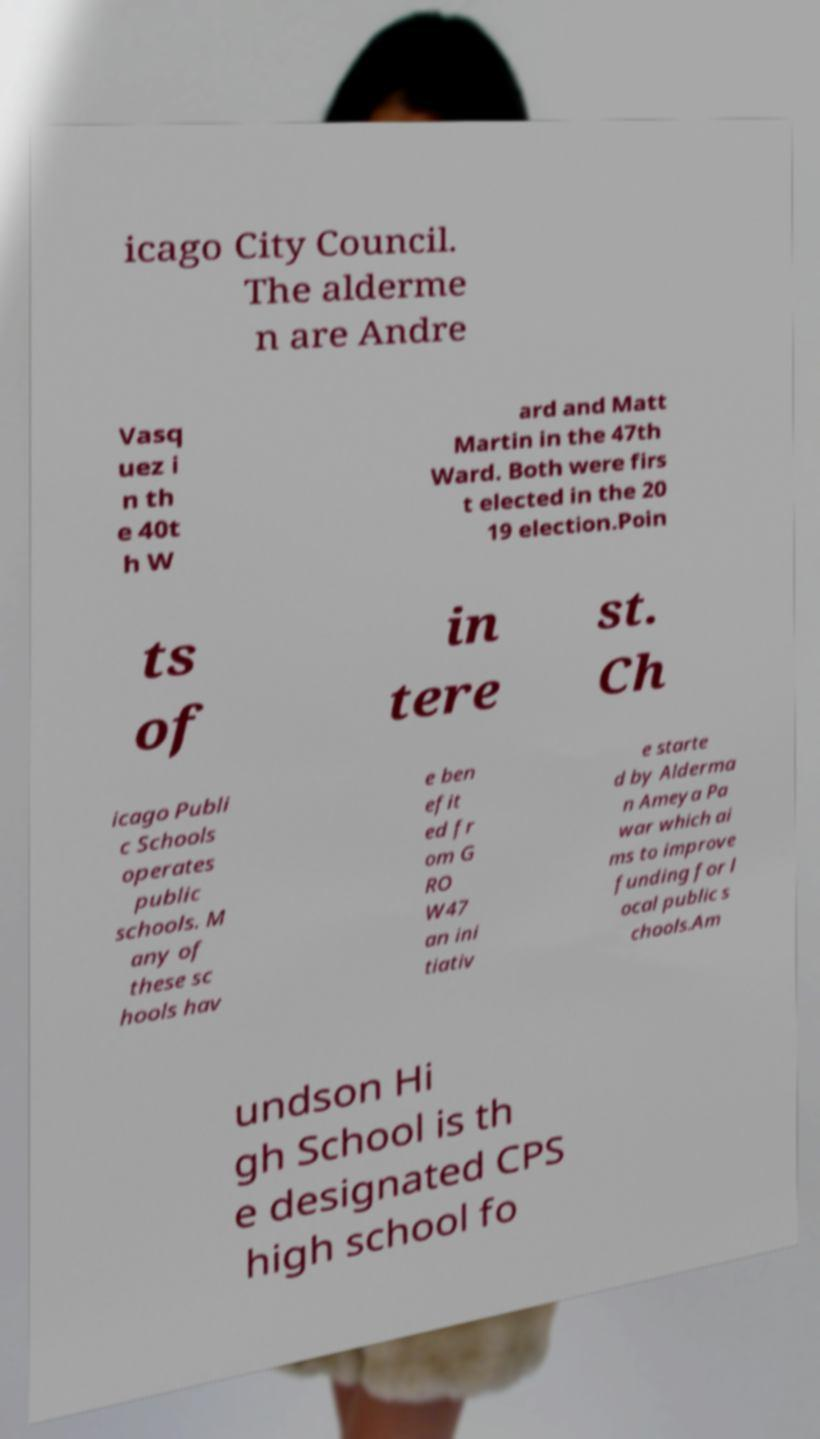Could you extract and type out the text from this image? icago City Council. The alderme n are Andre Vasq uez i n th e 40t h W ard and Matt Martin in the 47th Ward. Both were firs t elected in the 20 19 election.Poin ts of in tere st. Ch icago Publi c Schools operates public schools. M any of these sc hools hav e ben efit ed fr om G RO W47 an ini tiativ e starte d by Alderma n Ameya Pa war which ai ms to improve funding for l ocal public s chools.Am undson Hi gh School is th e designated CPS high school fo 